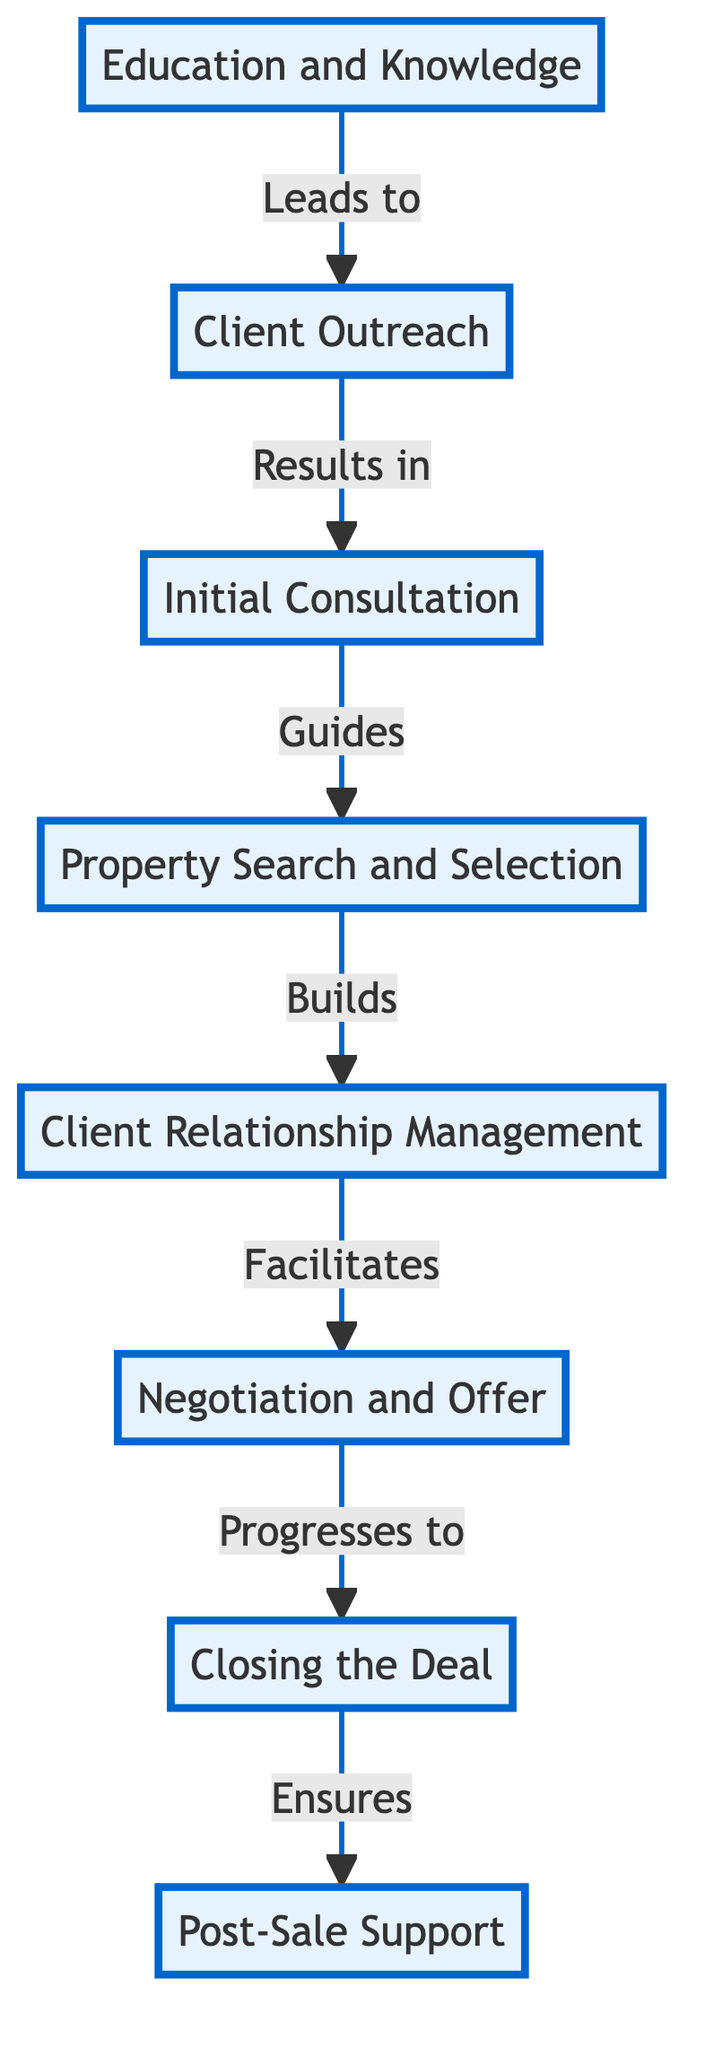What is the first step in building a robust client portfolio? The diagram indicates that the first step, as seen at the bottom, is "Education and Knowledge," which establishes the foundation for the subsequent steps in the process.
Answer: Education and Knowledge How many total steps are illustrated in the diagram? Counting each of the nodes from bottom to top, there are a total of 8 steps represented in the flowchart.
Answer: 8 What is the final step in the process? The last node that appears at the top of the diagram is "Post-Sale Support," indicating it is the final aspect of building a robust client portfolio.
Answer: Post-Sale Support Which two steps are directly connected to "Initial Consultation"? The diagram shows that "Initial Consultation" is directly connected to "Client Outreach" below it and to "Property Search and Selection" above it, indicating its function within the flow.
Answer: Client Outreach and Property Search and Selection How does "Client Relationship Management" impact the next step? "Client Relationship Management" leads to "Negotiation and Offer," meaning that maintaining a strong relationship directly facilitates the negotiation process for clients.
Answer: Facilitates What distinguished role does "Education and Knowledge" play in the overall process? As the foundational node at the bottom, "Education and Knowledge" is crucial since it initiates all subsequent steps by ensuring the agent is informed and prepared.
Answer: Foundation What is the relationship between "Negotiation and Offer" and "Closing the Deal"? The diagram indicates that "Negotiation and Offer" progresses directly to "Closing the Deal," suggesting that successful negotiations are essential to reaching the closing stage in transactions.
Answer: Progresses to Which step comes after "Property Search and Selection"? According to the flow of the diagram, the step that follows "Property Search and Selection" is "Client Relationship Management."
Answer: Client Relationship Management 